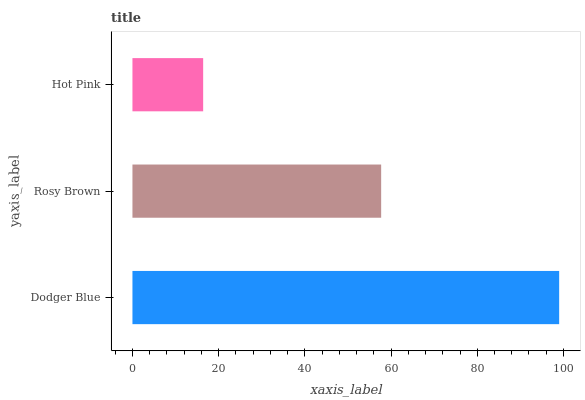Is Hot Pink the minimum?
Answer yes or no. Yes. Is Dodger Blue the maximum?
Answer yes or no. Yes. Is Rosy Brown the minimum?
Answer yes or no. No. Is Rosy Brown the maximum?
Answer yes or no. No. Is Dodger Blue greater than Rosy Brown?
Answer yes or no. Yes. Is Rosy Brown less than Dodger Blue?
Answer yes or no. Yes. Is Rosy Brown greater than Dodger Blue?
Answer yes or no. No. Is Dodger Blue less than Rosy Brown?
Answer yes or no. No. Is Rosy Brown the high median?
Answer yes or no. Yes. Is Rosy Brown the low median?
Answer yes or no. Yes. Is Dodger Blue the high median?
Answer yes or no. No. Is Hot Pink the low median?
Answer yes or no. No. 